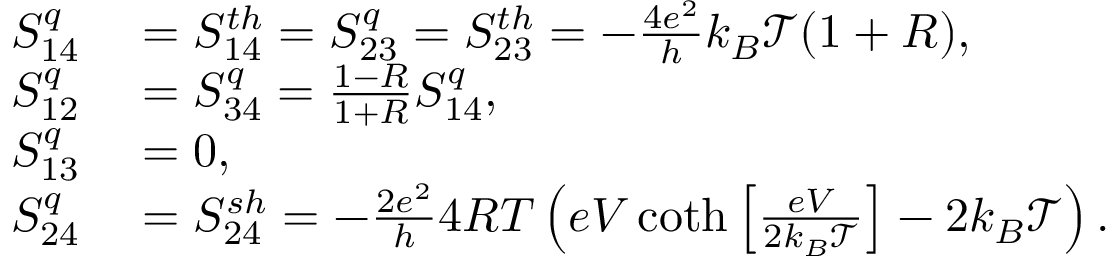Convert formula to latex. <formula><loc_0><loc_0><loc_500><loc_500>\begin{array} { r l } { S _ { 1 4 } ^ { q } } & = { S _ { 1 4 } ^ { t h } } = S _ { 2 3 } ^ { q } = { S _ { 2 3 } ^ { t h } } = - \frac { 4 e ^ { 2 } } { h } k _ { B } \mathcal { T } ( 1 + R ) , } \\ { S _ { 1 2 } ^ { q } } & = S _ { 3 4 } ^ { q } = \frac { 1 - R } { 1 + R } S _ { 1 4 } ^ { q } , } \\ { S _ { 1 3 } ^ { q } } & = 0 , } \\ { S _ { 2 4 } ^ { q } } & = { S _ { 2 4 } ^ { s h } } = - \frac { 2 e ^ { 2 } } { h } 4 R T \left ( e V \coth \left [ \frac { e V } { 2 k _ { B } \mathcal { T } } \right ] - 2 k _ { B } \mathcal { T } \right ) . } \end{array}</formula> 